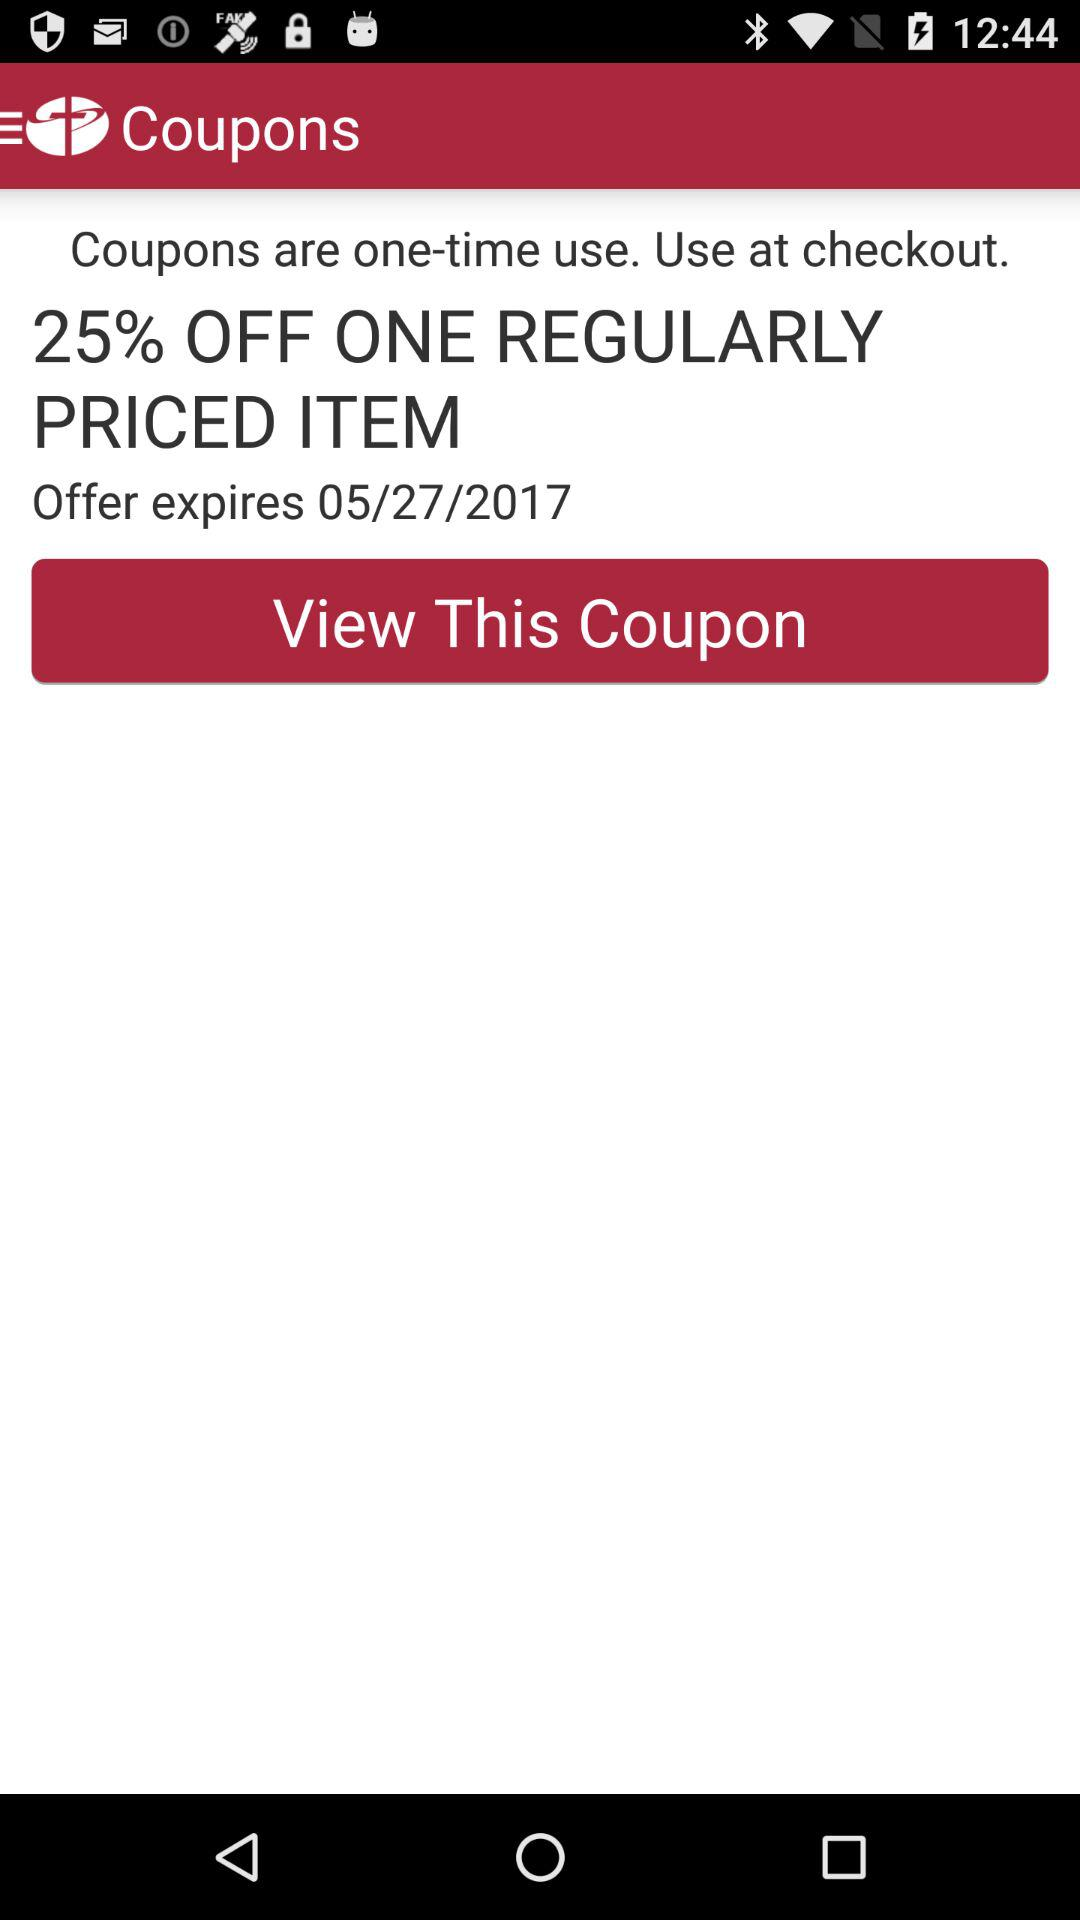How much is the discount?
Answer the question using a single word or phrase. 25% 